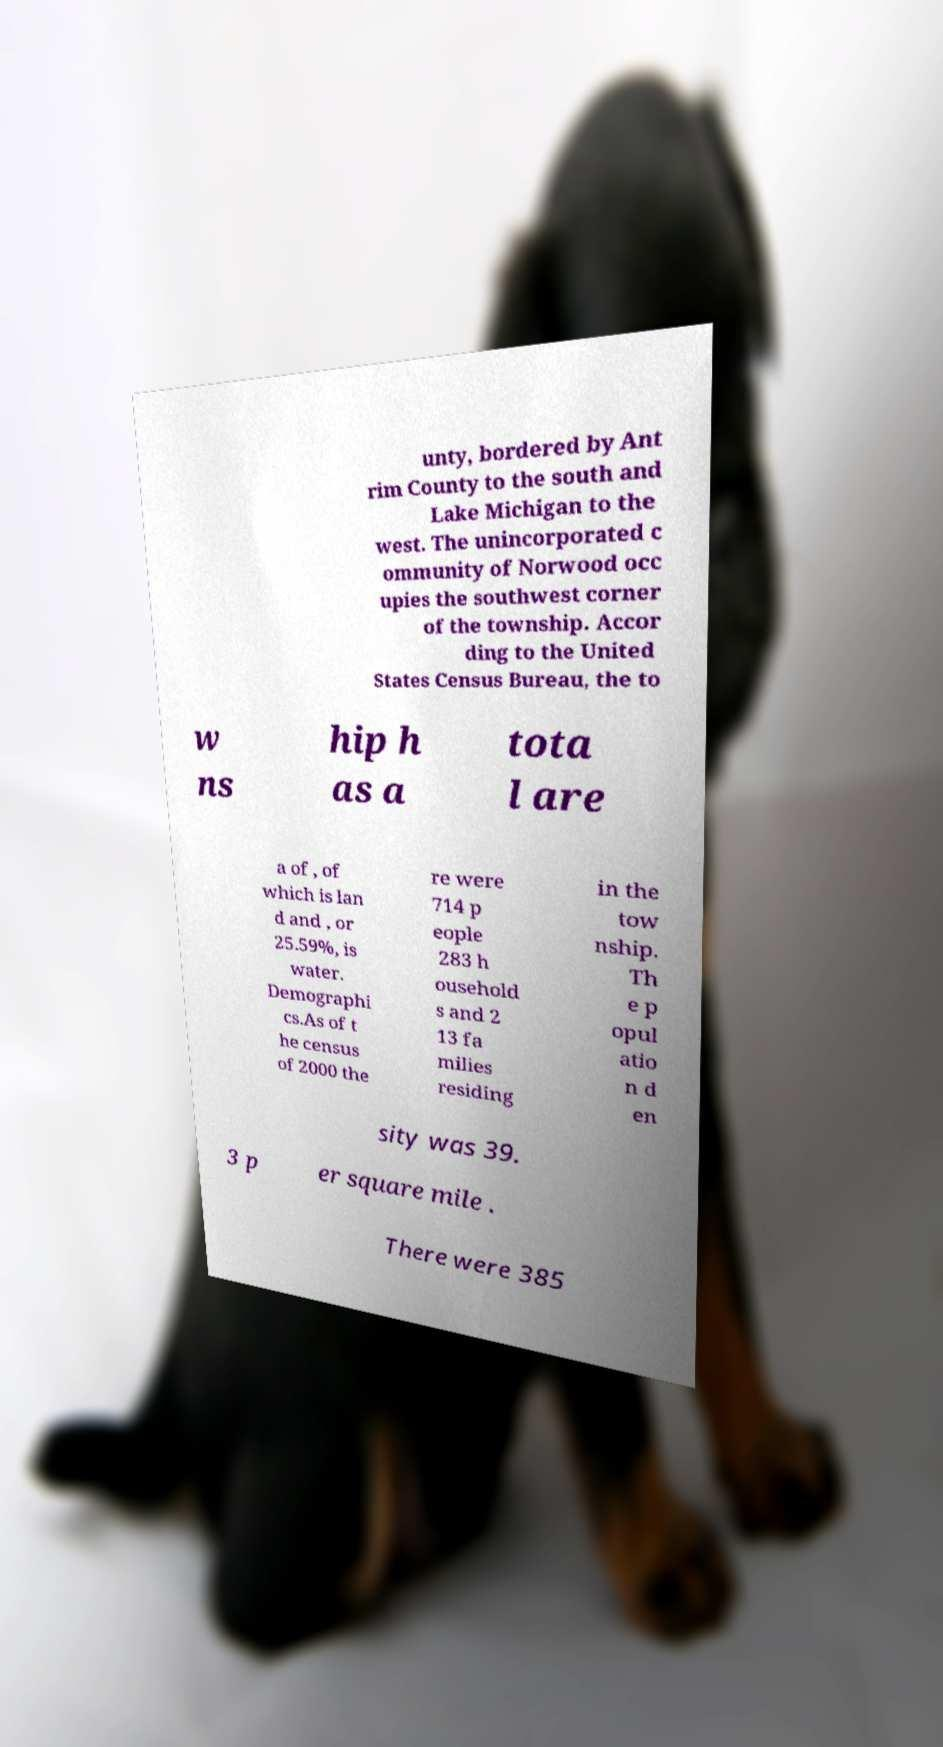Could you extract and type out the text from this image? unty, bordered by Ant rim County to the south and Lake Michigan to the west. The unincorporated c ommunity of Norwood occ upies the southwest corner of the township. Accor ding to the United States Census Bureau, the to w ns hip h as a tota l are a of , of which is lan d and , or 25.59%, is water. Demographi cs.As of t he census of 2000 the re were 714 p eople 283 h ousehold s and 2 13 fa milies residing in the tow nship. Th e p opul atio n d en sity was 39. 3 p er square mile . There were 385 